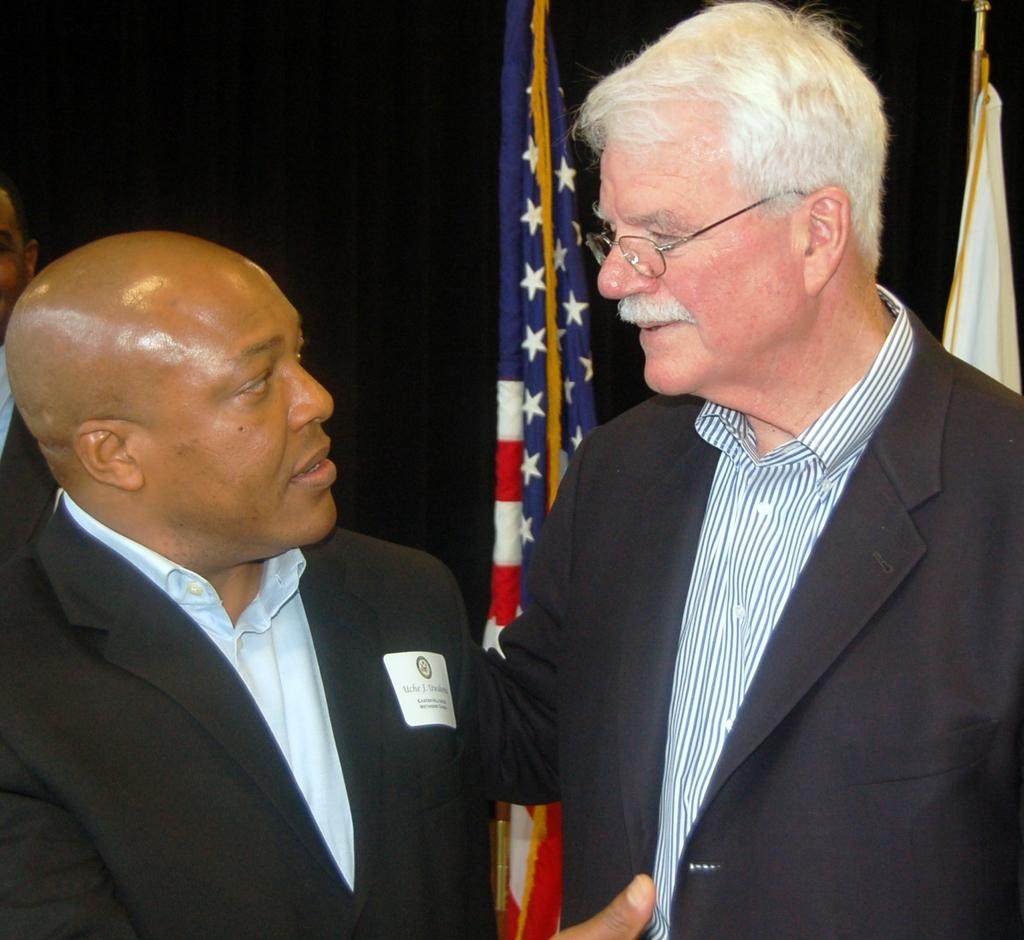What is the man in the image wearing on his face? The man in the image is wearing spectacles. How many men in the image are wearing blazers? There are two men wearing blazers in the image. Can you describe the person in the background of the image? There is a person in the background of the image, but no specific details are provided. What can be seen in the background of the image? There are flags in the background of the image. How would you describe the lighting in the image? The background of the image appears to be dark. What type of drum is being played by the person in the image? There is no drum present in the image. Can you describe the lamp that is illuminating the scene in the image? There is no lamp present in the image. 